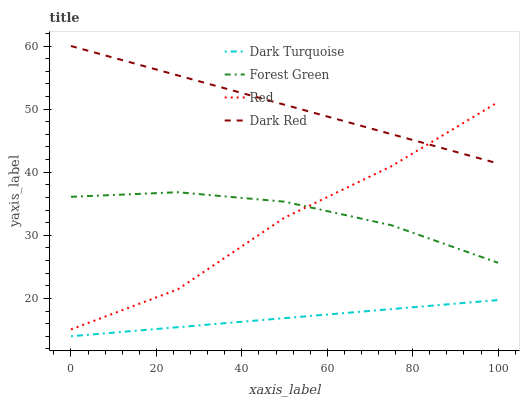Does Dark Turquoise have the minimum area under the curve?
Answer yes or no. Yes. Does Dark Red have the maximum area under the curve?
Answer yes or no. Yes. Does Forest Green have the minimum area under the curve?
Answer yes or no. No. Does Forest Green have the maximum area under the curve?
Answer yes or no. No. Is Dark Turquoise the smoothest?
Answer yes or no. Yes. Is Red the roughest?
Answer yes or no. Yes. Is Forest Green the smoothest?
Answer yes or no. No. Is Forest Green the roughest?
Answer yes or no. No. Does Dark Turquoise have the lowest value?
Answer yes or no. Yes. Does Forest Green have the lowest value?
Answer yes or no. No. Does Dark Red have the highest value?
Answer yes or no. Yes. Does Forest Green have the highest value?
Answer yes or no. No. Is Forest Green less than Dark Red?
Answer yes or no. Yes. Is Forest Green greater than Dark Turquoise?
Answer yes or no. Yes. Does Red intersect Dark Red?
Answer yes or no. Yes. Is Red less than Dark Red?
Answer yes or no. No. Is Red greater than Dark Red?
Answer yes or no. No. Does Forest Green intersect Dark Red?
Answer yes or no. No. 